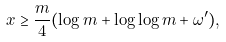<formula> <loc_0><loc_0><loc_500><loc_500>x \geq \frac { m } { 4 } ( \log m + \log \log m + \omega ^ { \prime } ) ,</formula> 